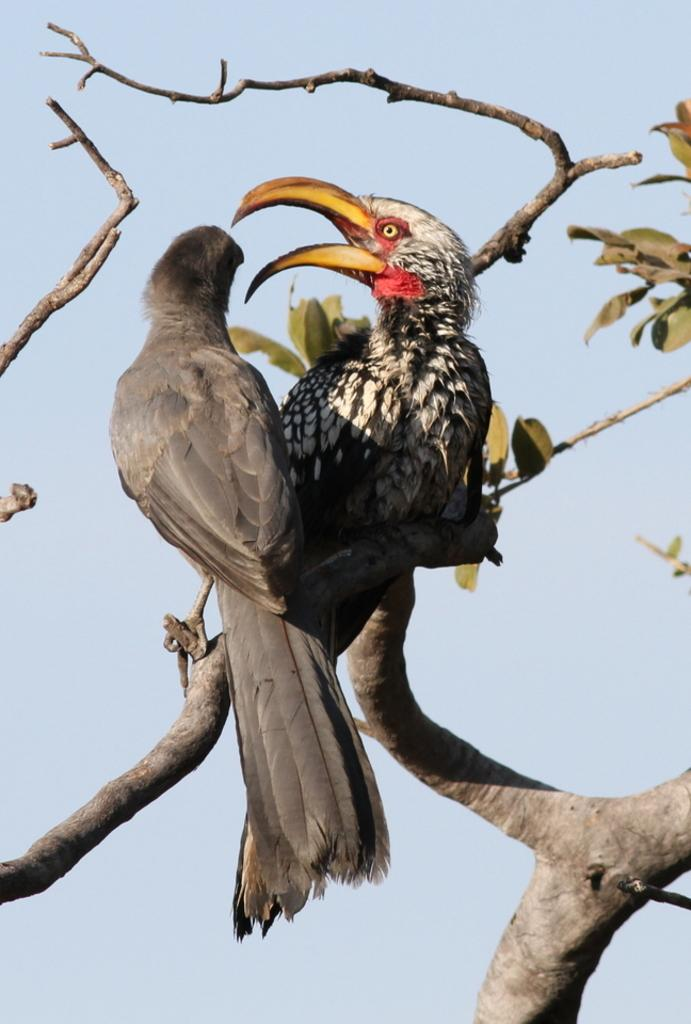What type of bird is the main subject of the picture? There is a hornbill in the picture. Are there any other birds in the image? Yes, there is another bird standing beside the hornbill. What type of train can be seen in the background of the image? There is no train present in the image; it features a hornbill and another bird. What type of map is visible on the ground near the birds? There is no map present in the image; it features a hornbill and another bird. 